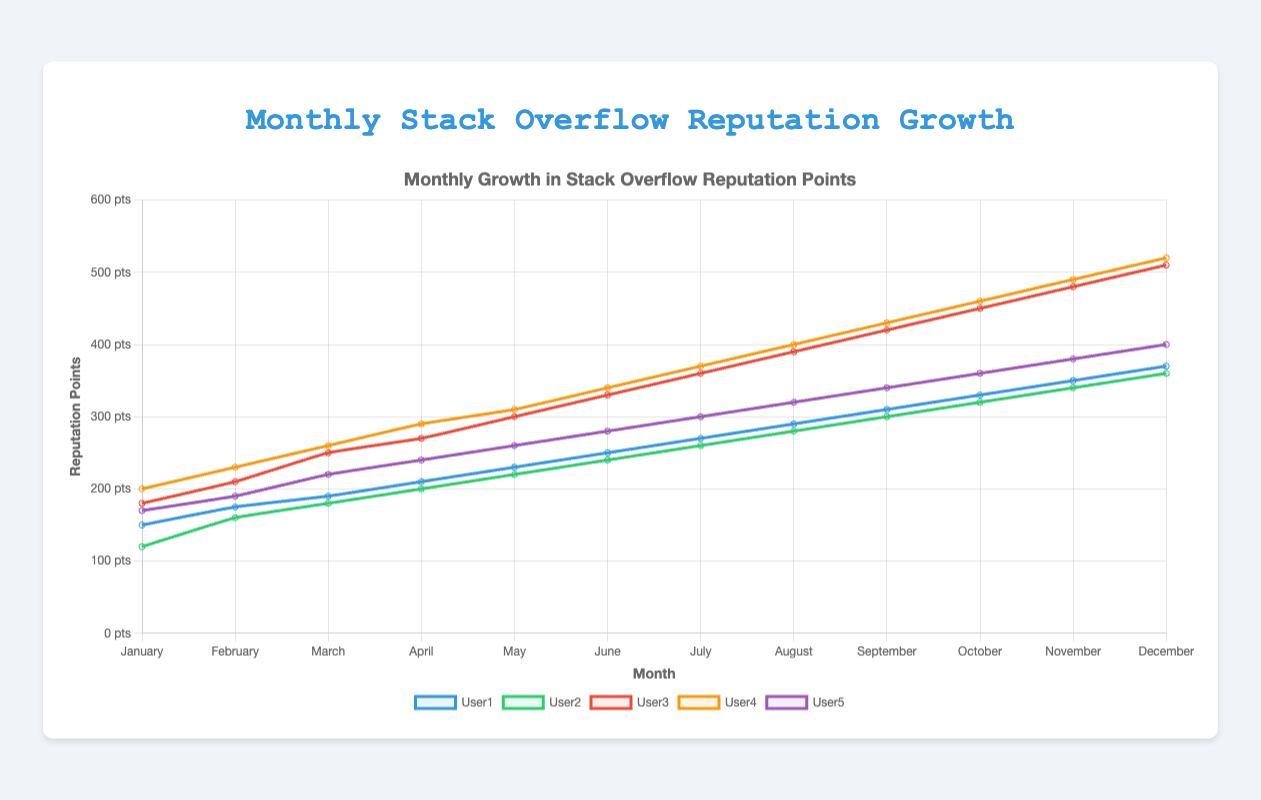Which month showed the highest reputation growth for User3? Looking at the line chart, trace the values for User3's line (red) to identify the month with the highest peak. December shows the highest value for User3 at 510 points.
Answer: December How many more reputation points did User4 gain in May compared to February? Identify User4's reputation points in February (230) and May (310) on the yellow line. Subtract February's value from May's: 310 - 230 = 80 points.
Answer: 80 In which month did User2 surpass 300 reputation points for the first time? Follow User2's green line and observe the reputation points for each month. September is the first month where User2's reputation exceeds 300, with exactly 300 points.
Answer: September What is the average reputation growth for User5 from January to June? Sum User5's reputation points from January (170) to June (280): 170 + 190 + 220 + 240 + 260 + 280 = 1360. Divide by 6 months: 1360 / 6 ≈ 227.
Answer: 227 Which user showed the most consistent growth throughout the year? Examine the smoothness and consistency of each user’s line. User1’s blue line shows a steady and consistent upward trend with less fluctuation compared to others.
Answer: User1 How much total reputation did User1 gain from January to December? Calculate the difference in User1’s reputation points from January (150) to December (370). Total gain: 370 - 150 = 220 points.
Answer: 220 In which month did User5's reputation growth rate decrease compared to the previous month? Check User5’s purple line for months where the increase decreases. April to May (240 to 260) shows a slower growth compared to prior months.
Answer: May Compare the reputation points of User2 and User5 in August. Was User2 ahead or behind User5, and by how much? Note User2 (280) and User5 (320) values in August. User2 is behind User5 by 320 - 280 = 40 points.
Answer: Behind by 40 What is the combined reputation of User3 and User4 in March? Find the sums for User3 (250) and User4 (260) in March. Combined: 250 + 260 = 510 points.
Answer: 510 Which month recorded the highest overall reputation growth across all users? Observe sums of points for each month. December (370 + 360 + 510 + 520 + 400 = 2160) has the highest combined reputation growth.
Answer: December 